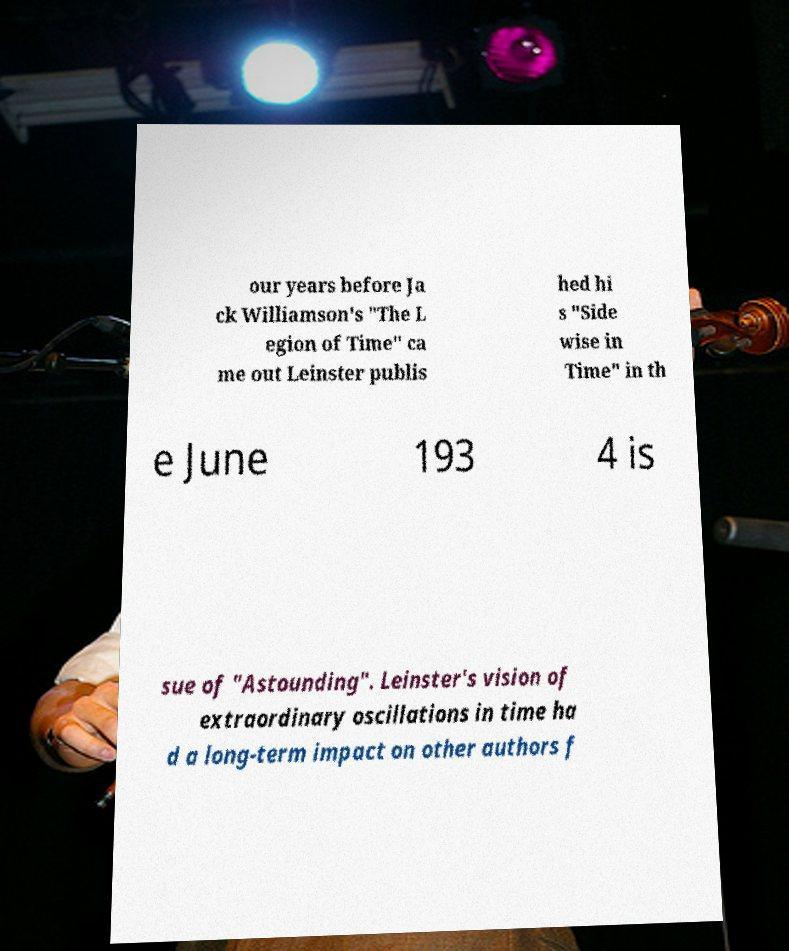Please identify and transcribe the text found in this image. our years before Ja ck Williamson's "The L egion of Time" ca me out Leinster publis hed hi s "Side wise in Time" in th e June 193 4 is sue of "Astounding". Leinster's vision of extraordinary oscillations in time ha d a long-term impact on other authors f 